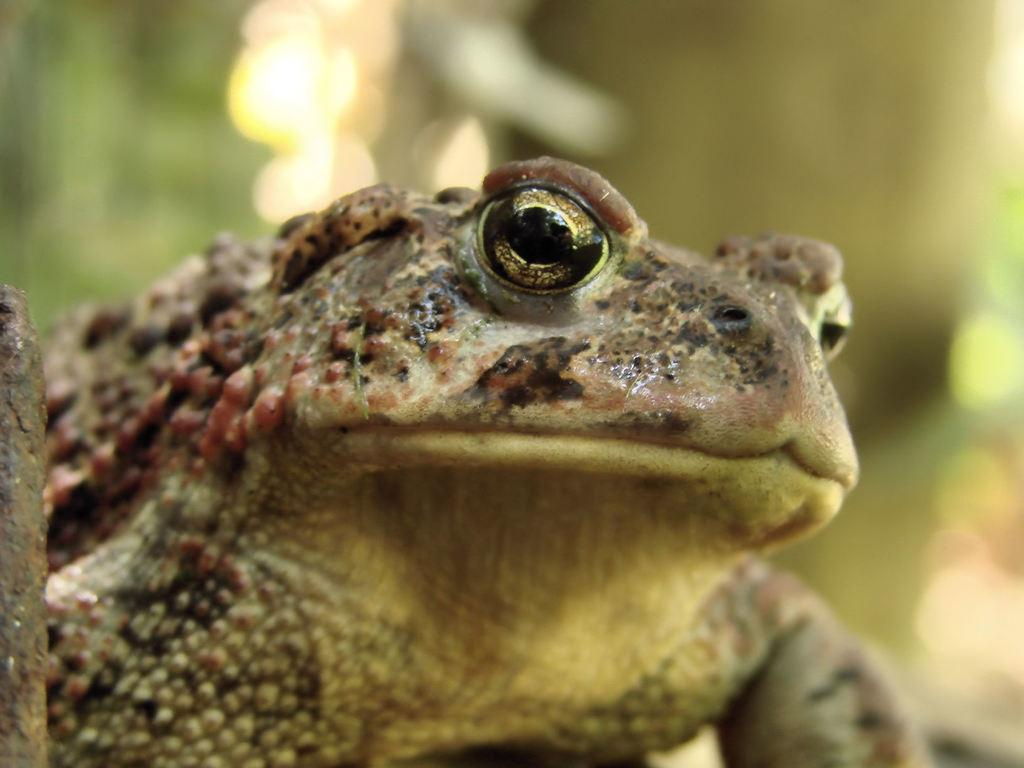What is the main subject of the image? There is a frog in the image. Can you describe the background of the image? The background of the image is blurred. What type of guide is the frog holding in the image? There is no guide present in the image, as it features a frog with a blurred background. 